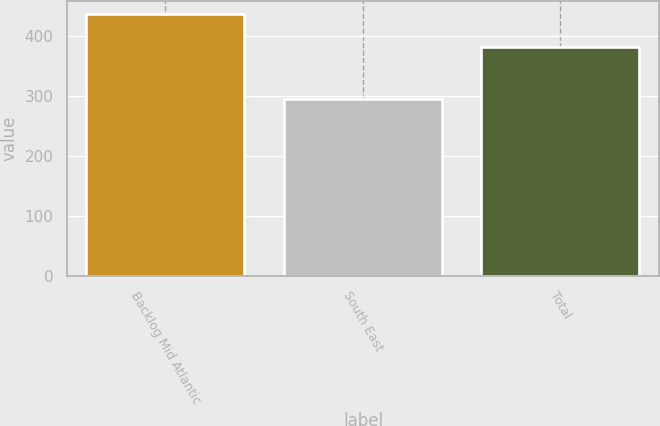Convert chart. <chart><loc_0><loc_0><loc_500><loc_500><bar_chart><fcel>Backlog Mid Atlantic<fcel>South East<fcel>Total<nl><fcel>435.3<fcel>294.6<fcel>381.3<nl></chart> 